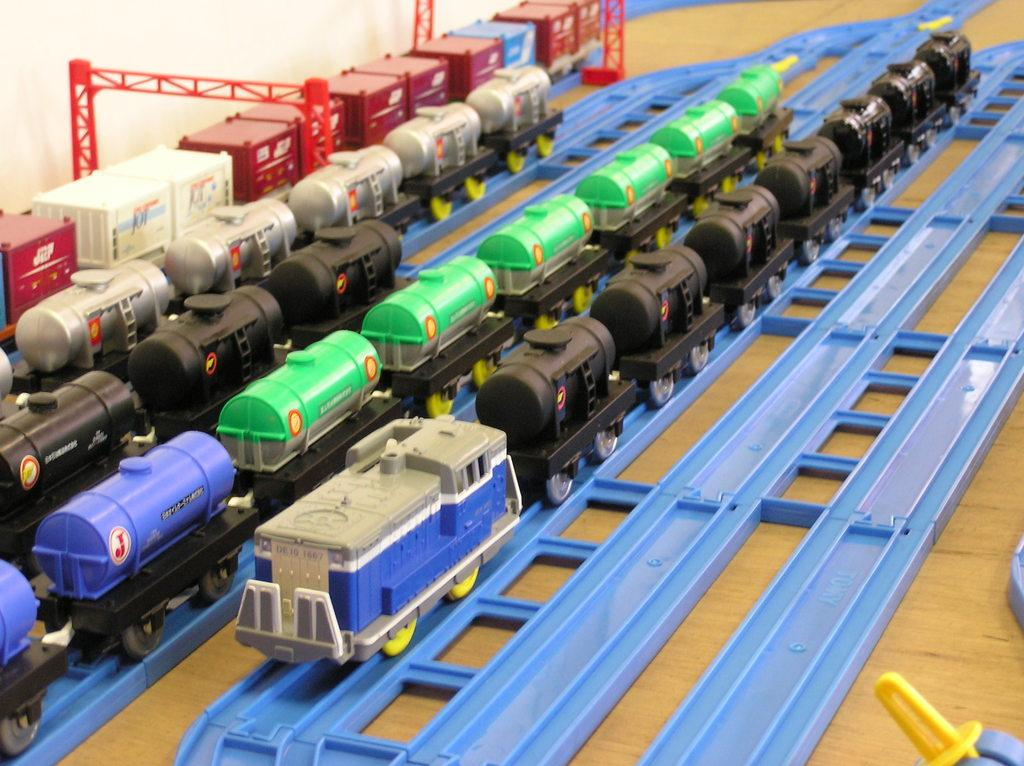What type of furniture is present in the image? There is a table in the image. What objects are on the table? There are train toys on the table. How are the train toys arranged on the table? The train toys are on tracks. What type of powder is being used to clean the train toys in the image? There is no powder or cleaning activity present in the image; it only shows train toys on tracks. 